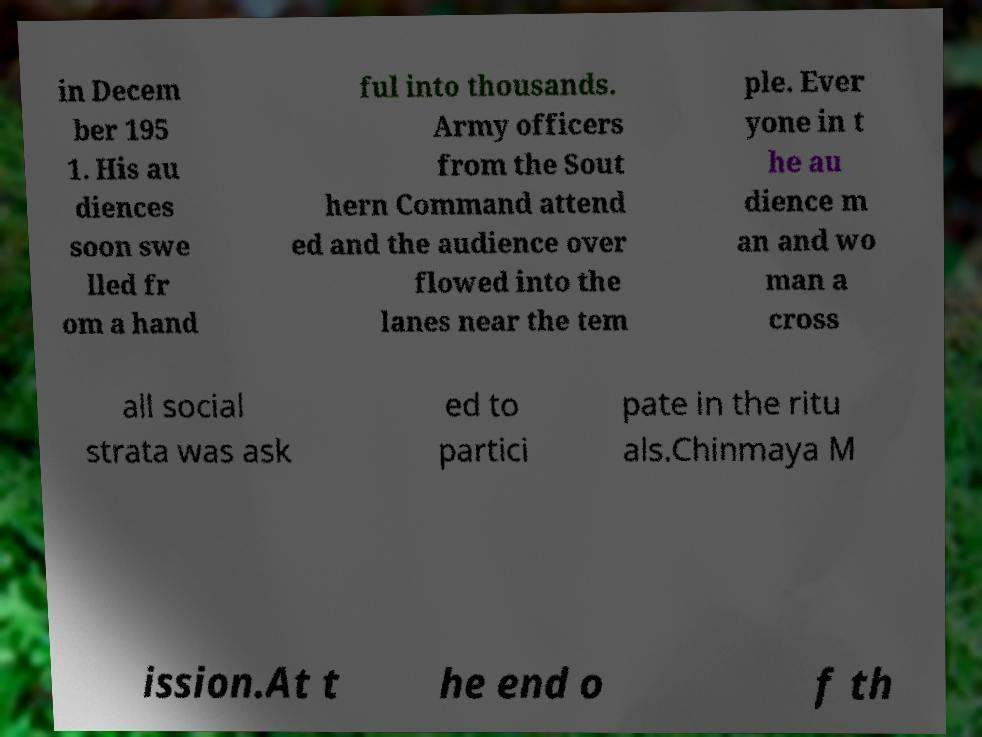There's text embedded in this image that I need extracted. Can you transcribe it verbatim? in Decem ber 195 1. His au diences soon swe lled fr om a hand ful into thousands. Army officers from the Sout hern Command attend ed and the audience over flowed into the lanes near the tem ple. Ever yone in t he au dience m an and wo man a cross all social strata was ask ed to partici pate in the ritu als.Chinmaya M ission.At t he end o f th 